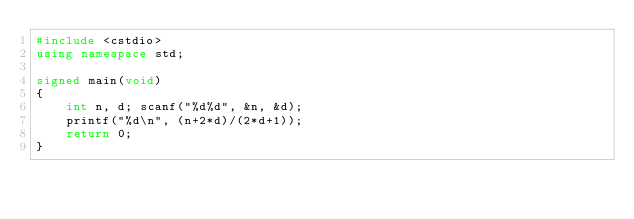<code> <loc_0><loc_0><loc_500><loc_500><_C++_>#include <cstdio>
using namespace std;

signed main(void)
{
	int n, d; scanf("%d%d", &n, &d);
	printf("%d\n", (n+2*d)/(2*d+1));
	return 0;
}</code> 